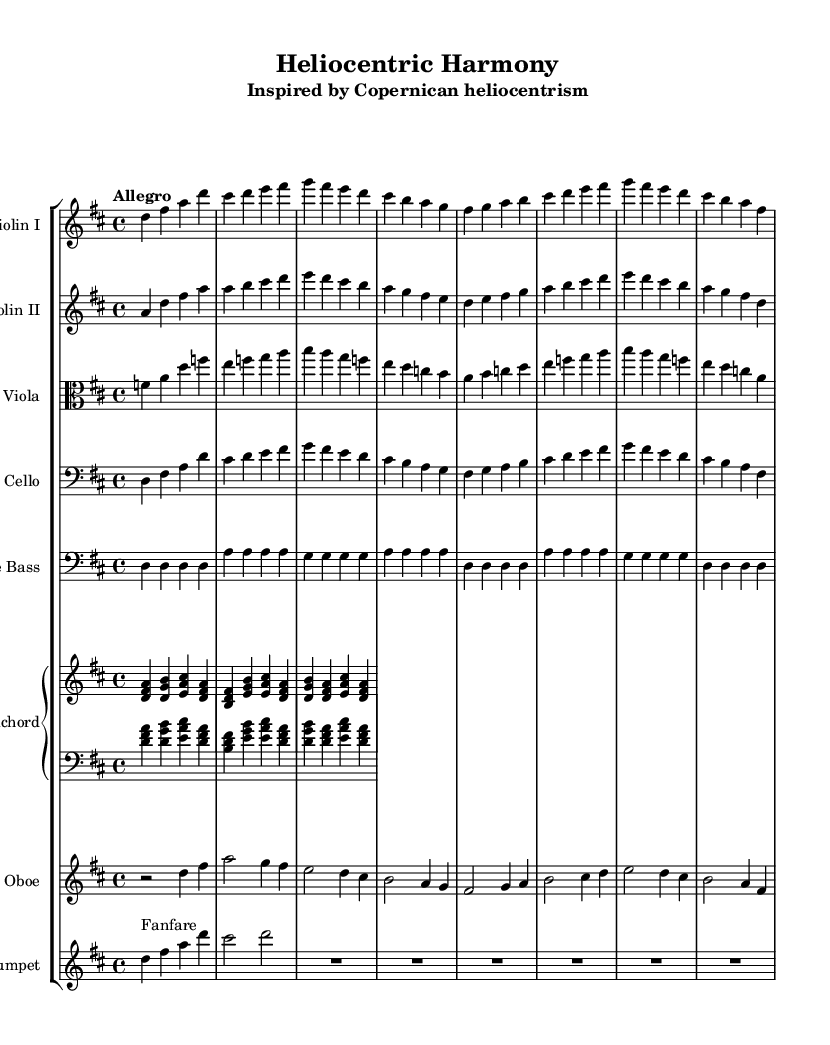What is the key signature of this music? The key signature is D major, indicated by two sharps (F# and C#) at the beginning of the staff.
Answer: D major What is the time signature of this piece? The time signature is 4/4, shown at the beginning of the score, which indicates that there are four beats per measure.
Answer: 4/4 How many measures are in the score? By counting the individual barlines present in the system, there are 16 measures in total.
Answer: 16 What is the tempo marking of this piece? The tempo marking is "Allegro," which suggests a quick and lively tempo; this is typically indicated above the staff at the beginning.
Answer: Allegro Which instruments are included in this orchestral piece? The instruments listed include Violin I, Violin II, Viola, Cello, Double Bass, Harpsichord, Oboe, and Trumpet, as indicated in the score layout.
Answer: Violin I, Violin II, Viola, Cello, Double Bass, Harpsichord, Oboe, Trumpet What thematic inspiration does this piece have? The subtitle "Inspired by Copernican heliocentrism" provides the thematic inspiration, relating the music to the scientific discovery of heliocentrism proposed by Copernicus.
Answer: Copernican heliocentrism What is the final pitch of the first violin part? The first violin part ends on an F-sharp, which can be determined by the last note in the part's written measures.
Answer: F-sharp 